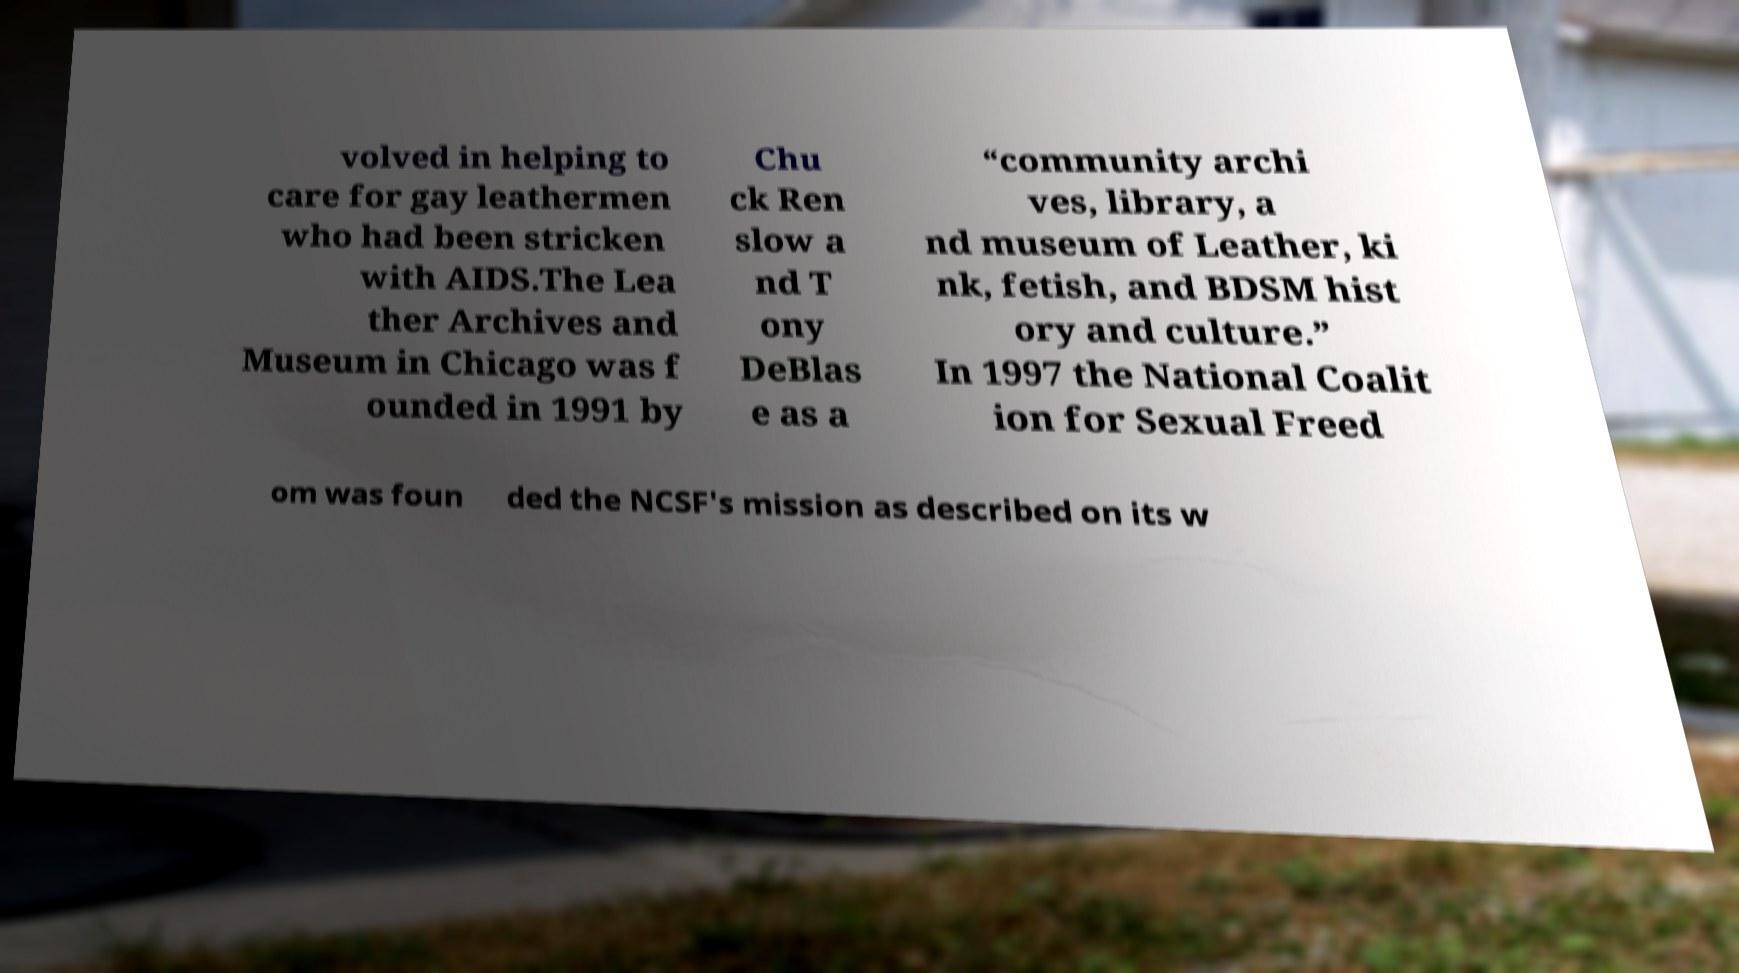Can you accurately transcribe the text from the provided image for me? volved in helping to care for gay leathermen who had been stricken with AIDS.The Lea ther Archives and Museum in Chicago was f ounded in 1991 by Chu ck Ren slow a nd T ony DeBlas e as a “community archi ves, library, a nd museum of Leather, ki nk, fetish, and BDSM hist ory and culture.” In 1997 the National Coalit ion for Sexual Freed om was foun ded the NCSF's mission as described on its w 